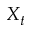Convert formula to latex. <formula><loc_0><loc_0><loc_500><loc_500>X _ { t }</formula> 